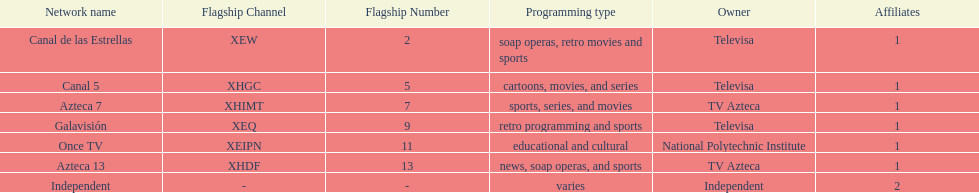How many networks does televisa own? 3. 